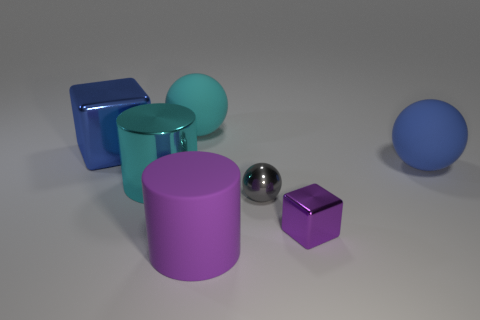Add 1 tiny blue metallic cubes. How many objects exist? 8 Subtract all big cyan matte balls. How many balls are left? 2 Add 5 small gray shiny balls. How many small gray shiny balls are left? 6 Add 3 gray shiny objects. How many gray shiny objects exist? 4 Subtract all purple cubes. How many cubes are left? 1 Subtract 0 red balls. How many objects are left? 7 Subtract all blocks. How many objects are left? 5 Subtract 1 balls. How many balls are left? 2 Subtract all yellow balls. Subtract all blue blocks. How many balls are left? 3 Subtract all blue balls. How many yellow blocks are left? 0 